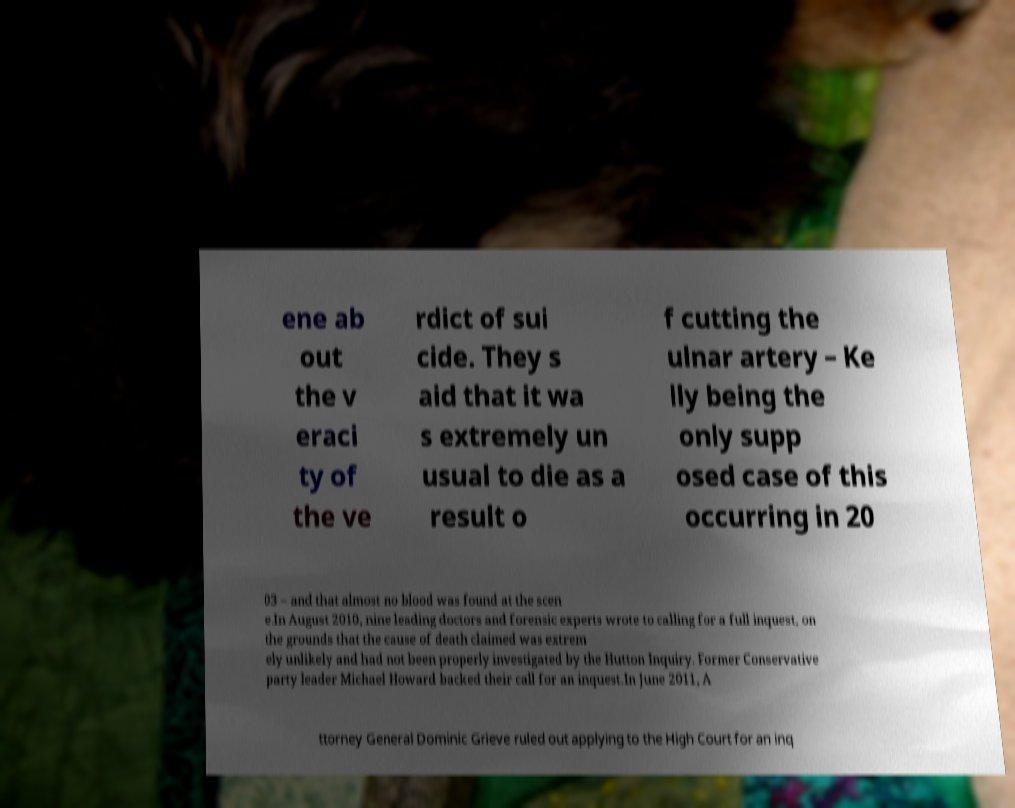Can you accurately transcribe the text from the provided image for me? ene ab out the v eraci ty of the ve rdict of sui cide. They s aid that it wa s extremely un usual to die as a result o f cutting the ulnar artery – Ke lly being the only supp osed case of this occurring in 20 03 – and that almost no blood was found at the scen e.In August 2010, nine leading doctors and forensic experts wrote to calling for a full inquest, on the grounds that the cause of death claimed was extrem ely unlikely and had not been properly investigated by the Hutton Inquiry. Former Conservative party leader Michael Howard backed their call for an inquest.In June 2011, A ttorney General Dominic Grieve ruled out applying to the High Court for an inq 